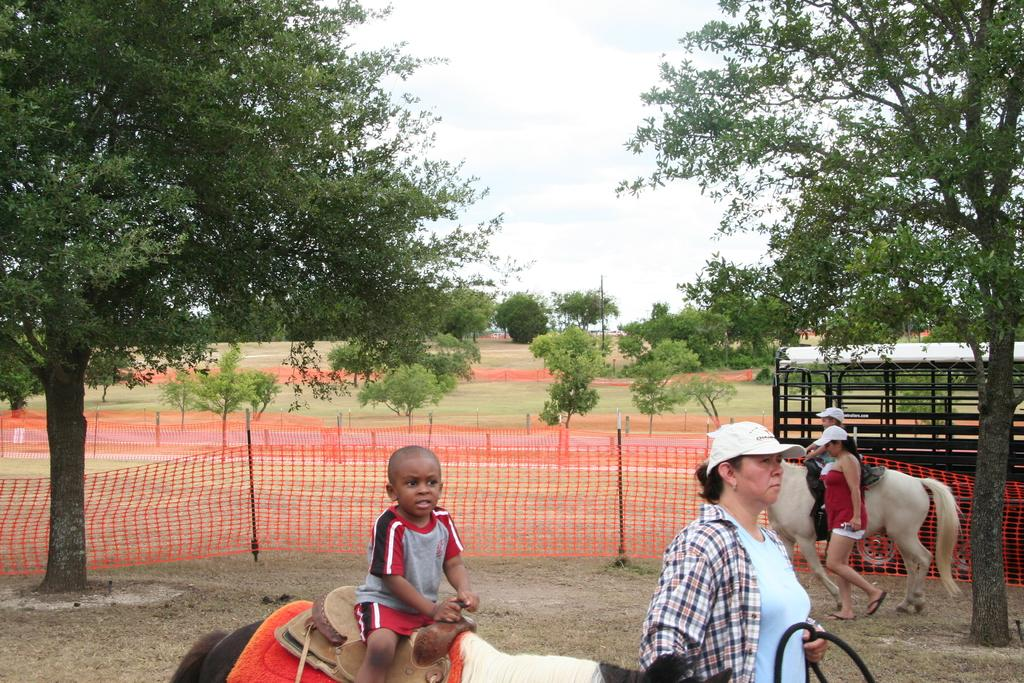How many people are in the image? There are two women standing in the image. What are the kids doing in the image? The kids are riding something in the image. What are the kids riding? The kids are riding what appears to be two horses. Are the horses part of a vehicle? Yes, the horses are part of a vehicle. What can be seen in the background of the image? Trees and the sky are visible in the background of the image. What is the color of the cloth tied around something in the image? The cloth is red. How does the image demonstrate respect for the environment? The image does not demonstrate respect for the environment, as it does not show any actions or objects related to environmental conservation. What type of muscle is being exercised by the kids while riding the horses? The image does not show any specific muscles being exercised, as it focuses on the kids riding horses rather than their physical activity. 